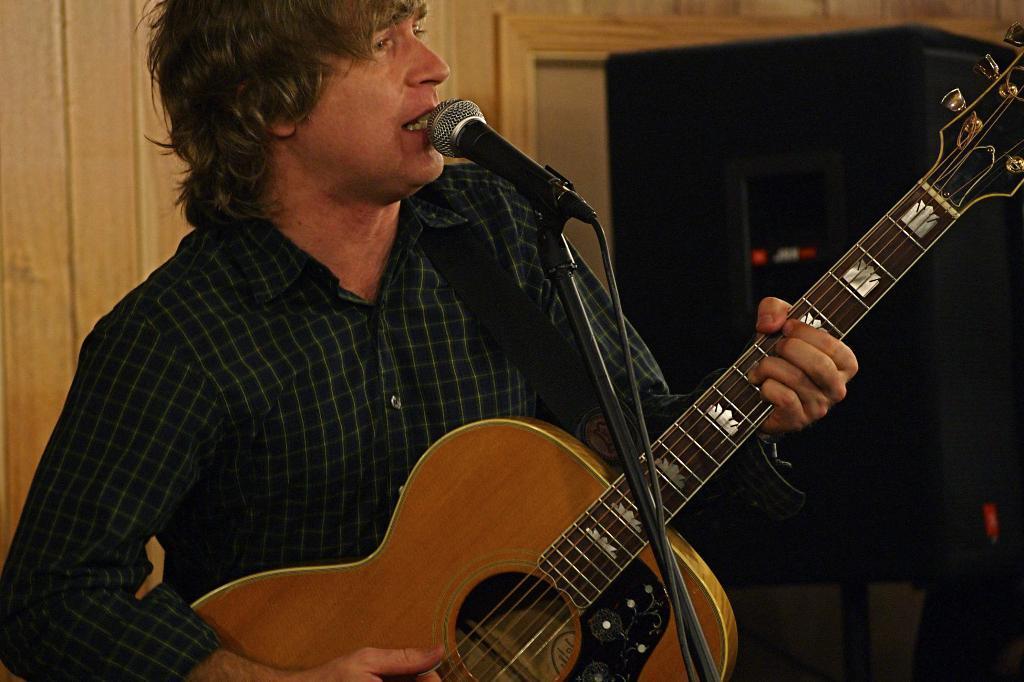In one or two sentences, can you explain what this image depicts? In this image there is a person standing and playing guitar and he is singing. At the back there is a speaker, at the front there is a microphone. 